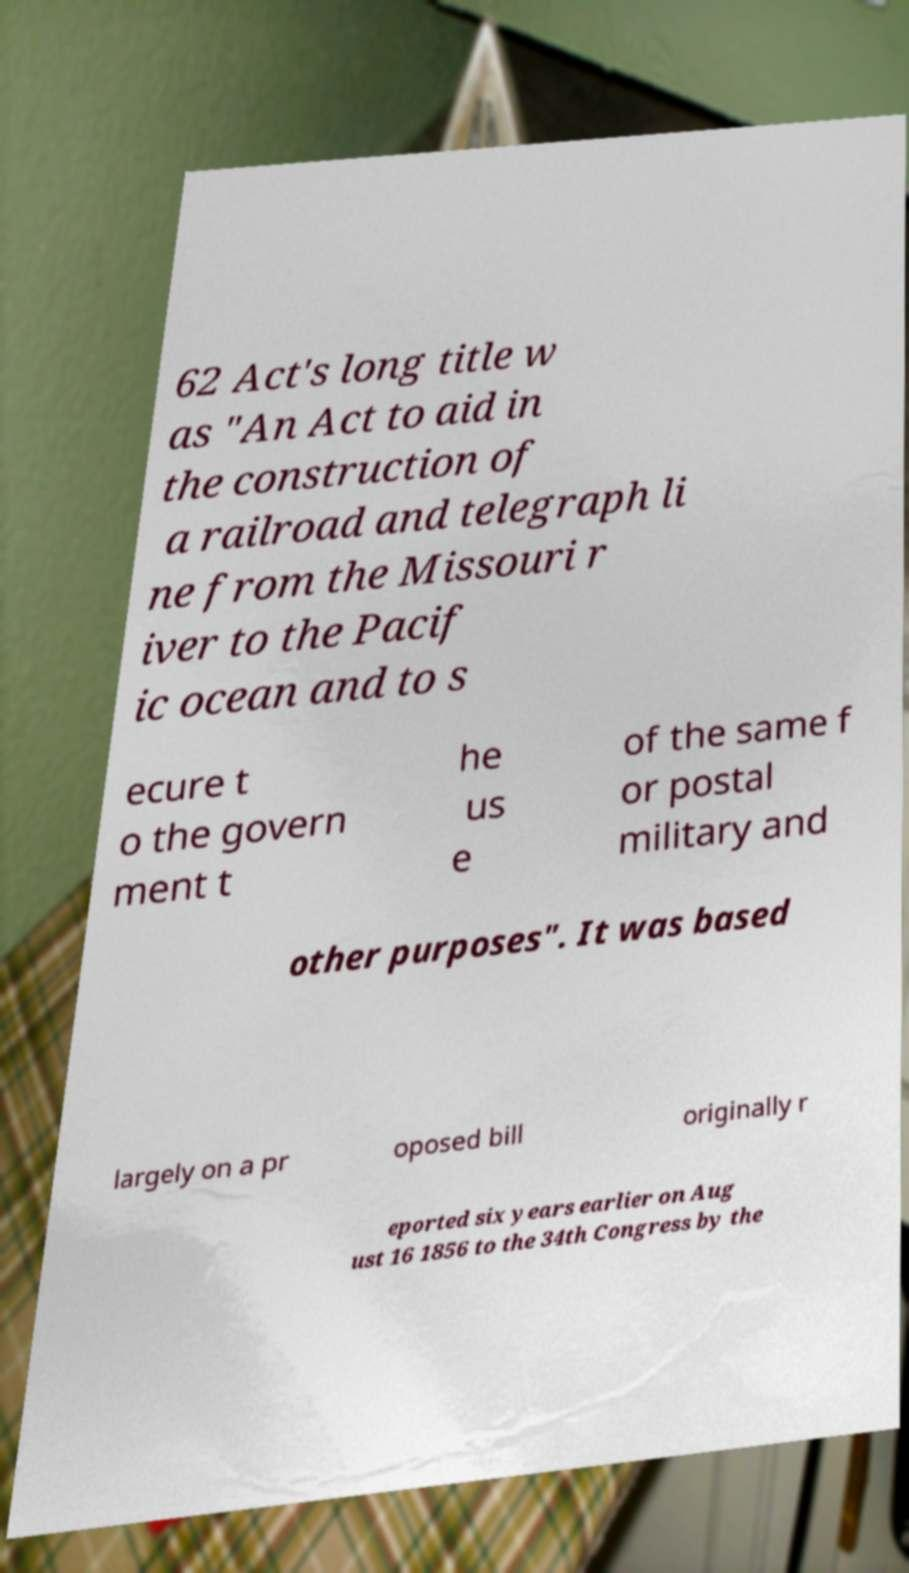What messages or text are displayed in this image? I need them in a readable, typed format. 62 Act's long title w as "An Act to aid in the construction of a railroad and telegraph li ne from the Missouri r iver to the Pacif ic ocean and to s ecure t o the govern ment t he us e of the same f or postal military and other purposes". It was based largely on a pr oposed bill originally r eported six years earlier on Aug ust 16 1856 to the 34th Congress by the 